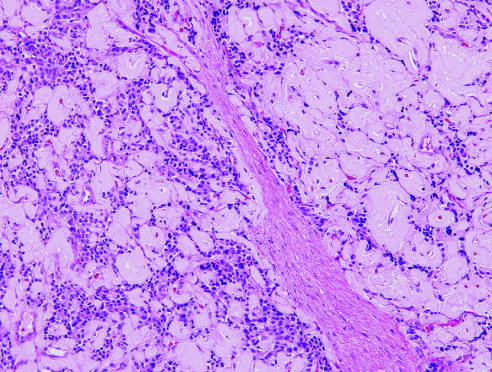what is also called islet cell tumor?
Answer the question using a single word or phrase. Pancreatic neuroendocrine tumor (pannet) 